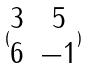<formula> <loc_0><loc_0><loc_500><loc_500>( \begin{matrix} 3 & 5 \\ 6 & - 1 \end{matrix} )</formula> 